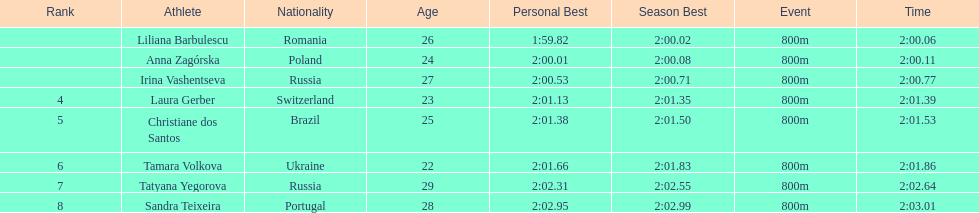Which country had the most finishers in the top 8? Russia. 